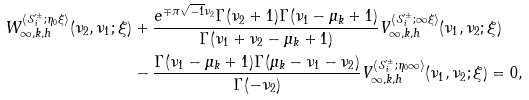Convert formula to latex. <formula><loc_0><loc_0><loc_500><loc_500>W ^ { \langle \mathcal { S } ^ { \prime \pm } _ { i } ; \eta _ { 0 } \xi \rangle } _ { \infty , k , h } ( \nu _ { 2 } , \nu _ { 1 } ; \xi ) & + \frac { e ^ { \mp \pi \sqrt { - 1 } \nu _ { 2 } } \Gamma ( \nu _ { 2 } + 1 ) \Gamma ( \nu _ { 1 } - \mu _ { k } + 1 ) } { \Gamma ( \nu _ { 1 } + \nu _ { 2 } - \mu _ { k } + 1 ) } V ^ { \langle \mathcal { S } ^ { \prime \pm } _ { i } ; \infty \xi \rangle } _ { \infty , k , h } ( \nu _ { 1 } , \nu _ { 2 } ; \xi ) \\ & - \frac { \Gamma ( \nu _ { 1 } - \mu _ { k } + 1 ) \Gamma ( \mu _ { k } - \nu _ { 1 } - \nu _ { 2 } ) } { \Gamma ( - \nu _ { 2 } ) } V ^ { \langle \mathcal { S } ^ { \prime \pm } _ { i } ; \eta _ { 0 } \infty \rangle } _ { \infty , k , h } ( \nu _ { 1 } , \nu _ { 2 } ; \xi ) = 0 ,</formula> 